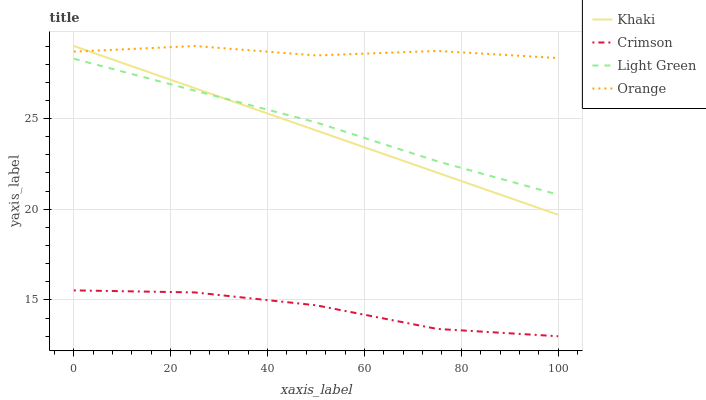Does Khaki have the minimum area under the curve?
Answer yes or no. No. Does Khaki have the maximum area under the curve?
Answer yes or no. No. Is Orange the smoothest?
Answer yes or no. No. Is Khaki the roughest?
Answer yes or no. No. Does Khaki have the lowest value?
Answer yes or no. No. Does Light Green have the highest value?
Answer yes or no. No. Is Crimson less than Khaki?
Answer yes or no. Yes. Is Khaki greater than Crimson?
Answer yes or no. Yes. Does Crimson intersect Khaki?
Answer yes or no. No. 